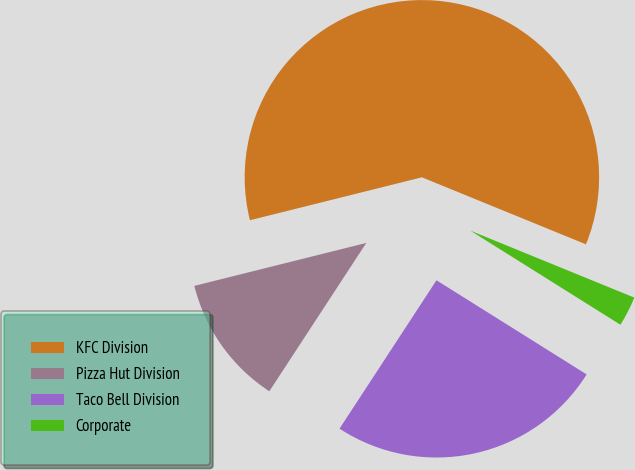<chart> <loc_0><loc_0><loc_500><loc_500><pie_chart><fcel>KFC Division<fcel>Pizza Hut Division<fcel>Taco Bell Division<fcel>Corporate<nl><fcel>60.06%<fcel>11.89%<fcel>25.3%<fcel>2.74%<nl></chart> 